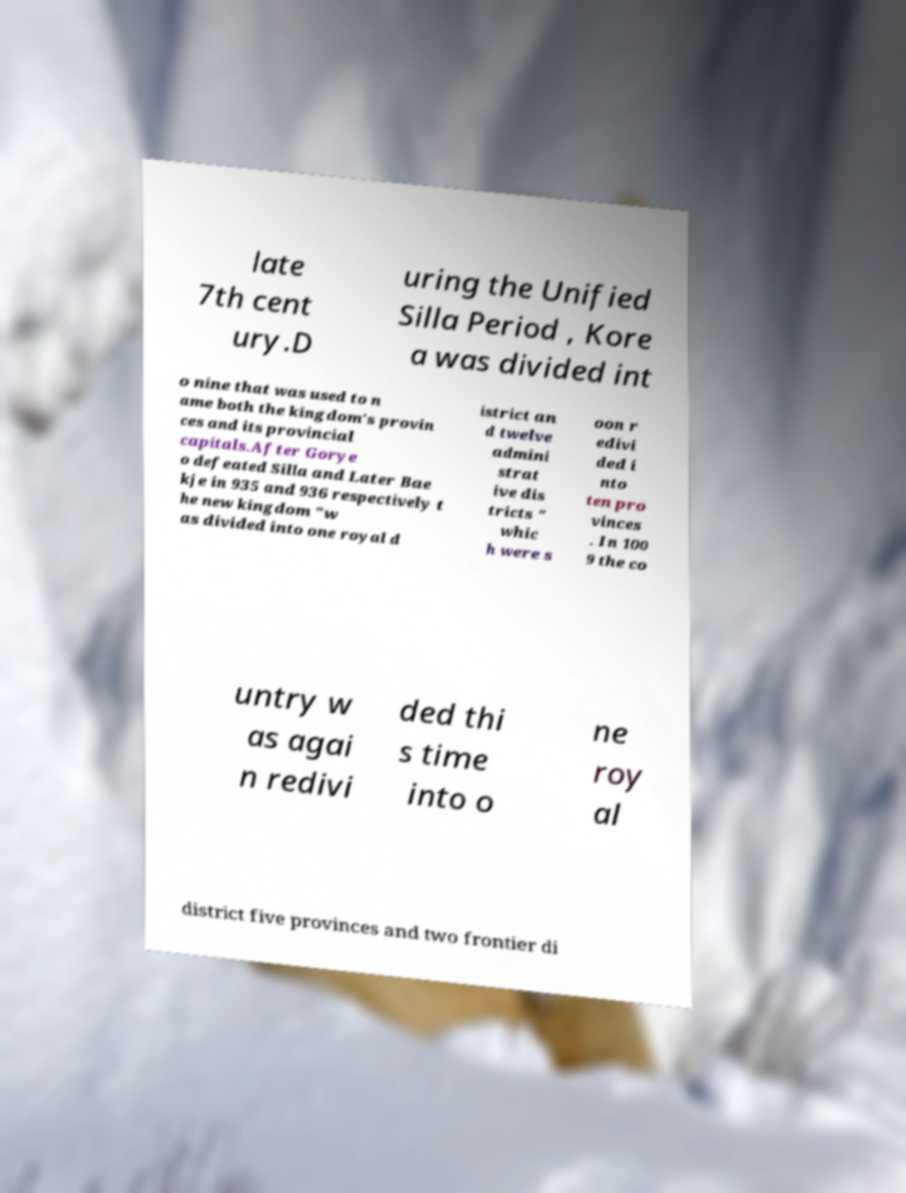I need the written content from this picture converted into text. Can you do that? late 7th cent ury.D uring the Unified Silla Period , Kore a was divided int o nine that was used to n ame both the kingdom's provin ces and its provincial capitals.After Gorye o defeated Silla and Later Bae kje in 935 and 936 respectively t he new kingdom "w as divided into one royal d istrict an d twelve admini strat ive dis tricts " whic h were s oon r edivi ded i nto ten pro vinces . In 100 9 the co untry w as agai n redivi ded thi s time into o ne roy al district five provinces and two frontier di 